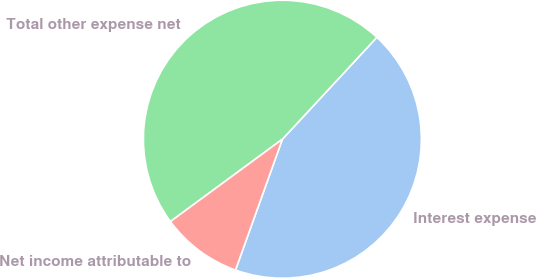<chart> <loc_0><loc_0><loc_500><loc_500><pie_chart><fcel>Interest expense<fcel>Total other expense net<fcel>Net income attributable to<nl><fcel>43.58%<fcel>46.99%<fcel>9.43%<nl></chart> 